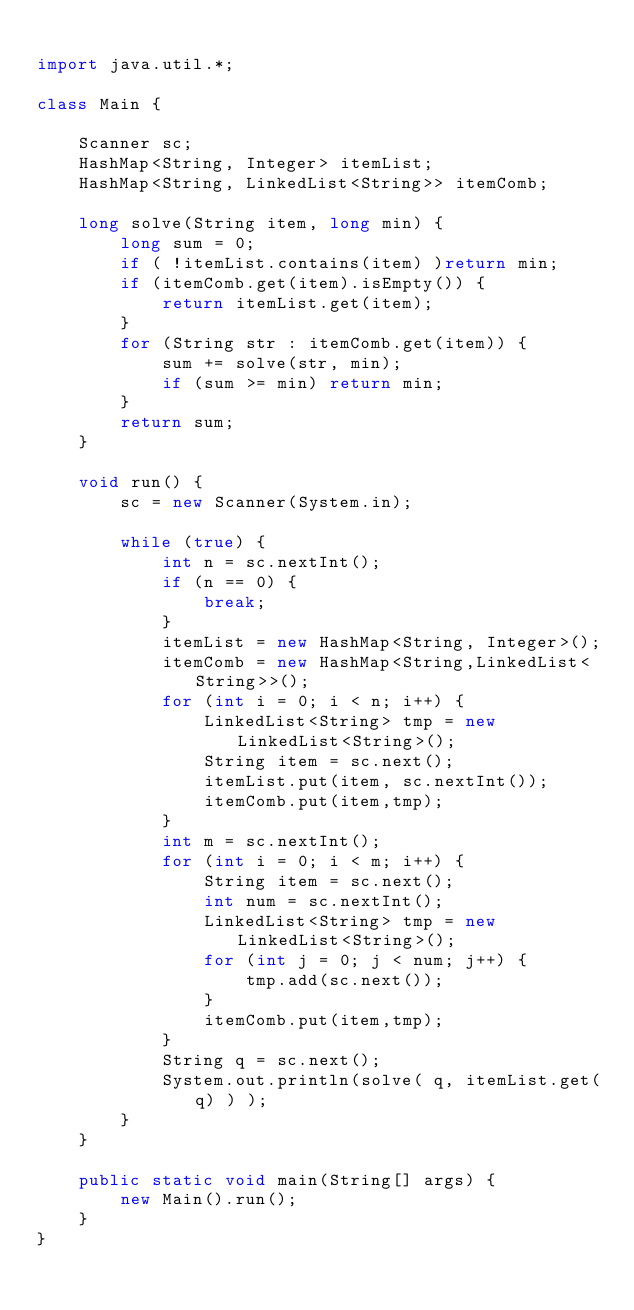<code> <loc_0><loc_0><loc_500><loc_500><_Java_>
import java.util.*;

class Main {

    Scanner sc;
    HashMap<String, Integer> itemList;
    HashMap<String, LinkedList<String>> itemComb;

    long solve(String item, long min) {
        long sum = 0;
        if ( !itemList.contains(item) )return min;
        if (itemComb.get(item).isEmpty()) {
            return itemList.get(item);
        }
        for (String str : itemComb.get(item)) {
            sum += solve(str, min);
            if (sum >= min) return min;
        }
        return sum;
    }

    void run() {
        sc = new Scanner(System.in);

        while (true) {
            int n = sc.nextInt();
            if (n == 0) {
                break;
            }
            itemList = new HashMap<String, Integer>();
            itemComb = new HashMap<String,LinkedList<String>>();
            for (int i = 0; i < n; i++) {
                LinkedList<String> tmp = new LinkedList<String>();
                String item = sc.next();
                itemList.put(item, sc.nextInt());
                itemComb.put(item,tmp);
            }
            int m = sc.nextInt();
            for (int i = 0; i < m; i++) {
                String item = sc.next();
                int num = sc.nextInt();
                LinkedList<String> tmp = new LinkedList<String>();
                for (int j = 0; j < num; j++) {
                    tmp.add(sc.next());
                }
                itemComb.put(item,tmp);
            }
            String q = sc.next();
            System.out.println(solve( q, itemList.get(q) ) );
        }
    }

    public static void main(String[] args) {
        new Main().run();
    }
}</code> 